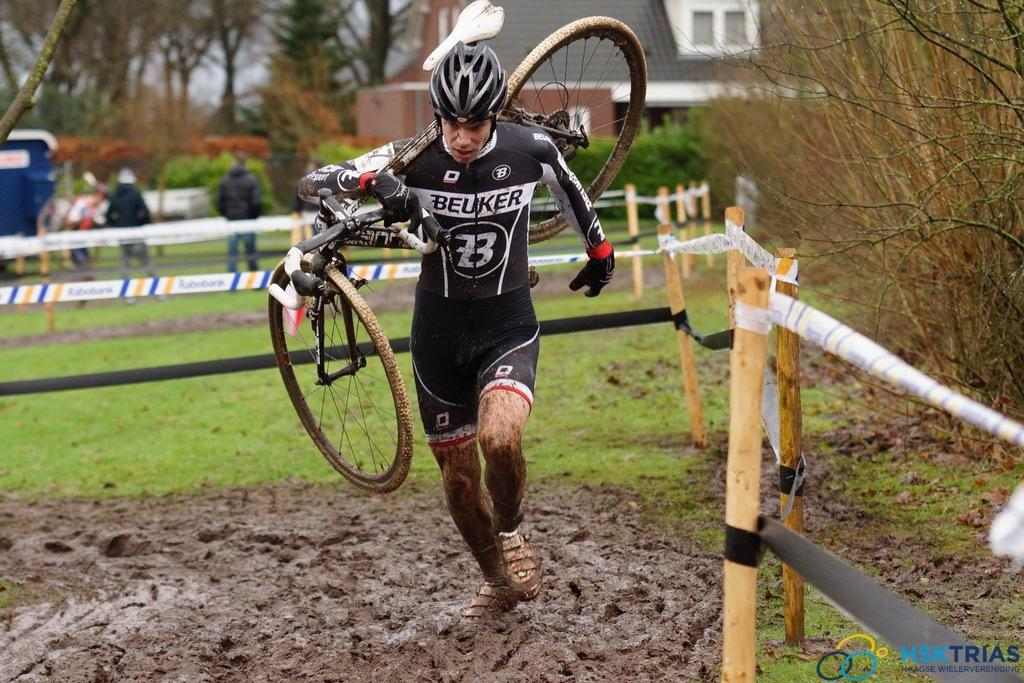<image>
Create a compact narrative representing the image presented. A person wears a helmet and a Beuker outfit as they run through the mud. 